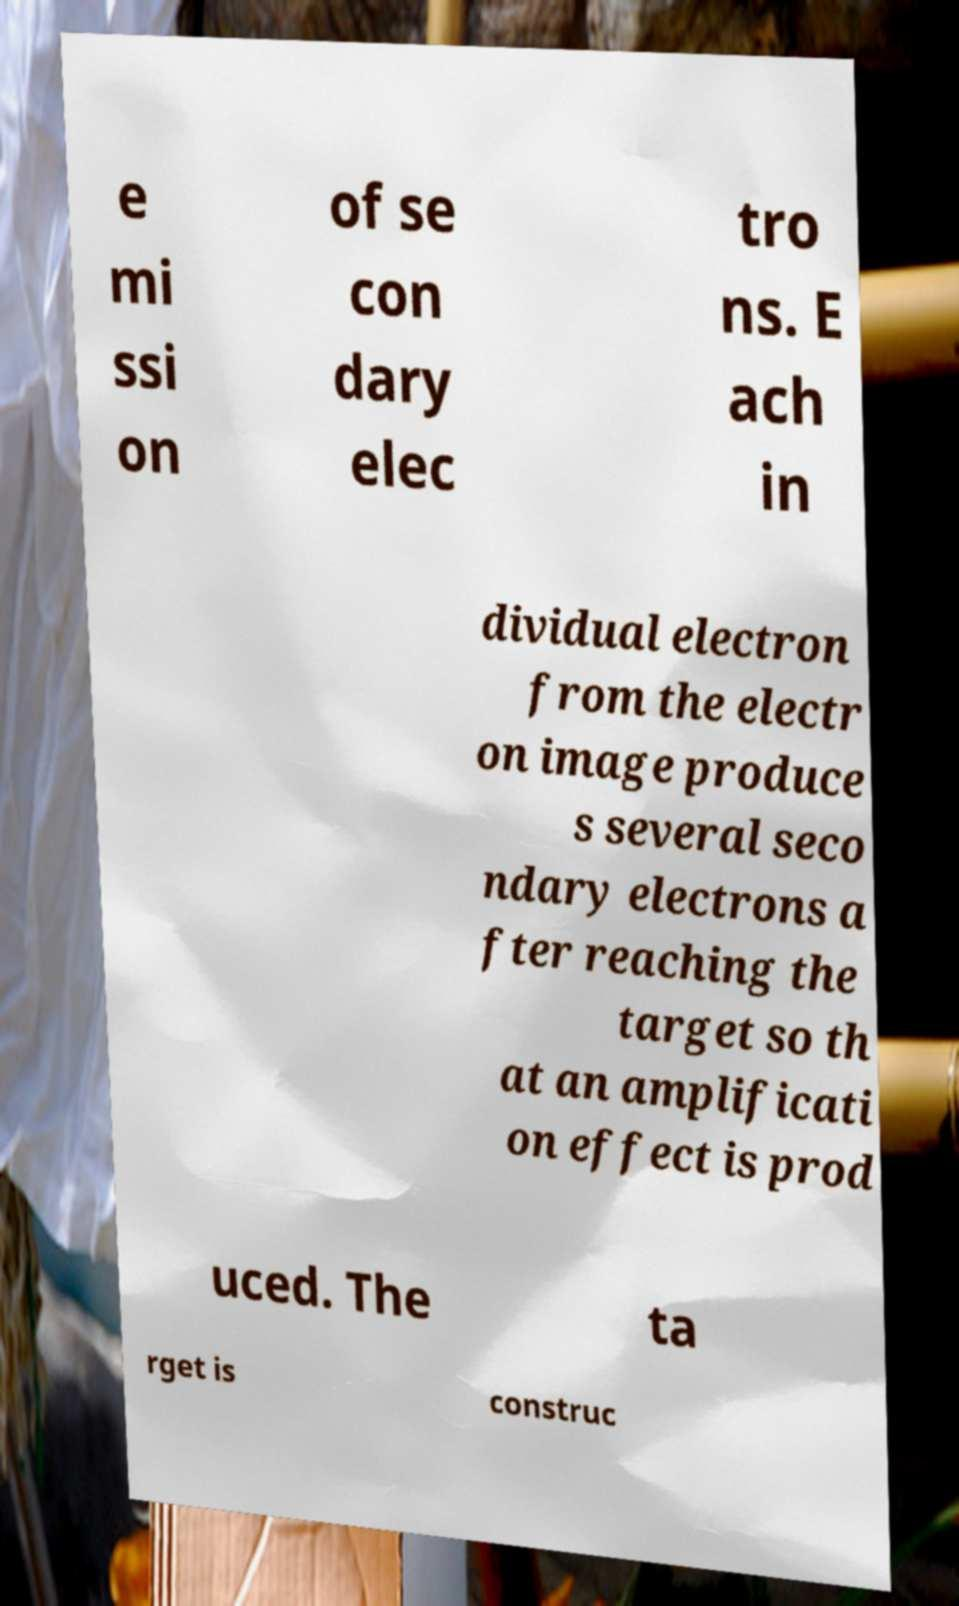Can you accurately transcribe the text from the provided image for me? e mi ssi on of se con dary elec tro ns. E ach in dividual electron from the electr on image produce s several seco ndary electrons a fter reaching the target so th at an amplificati on effect is prod uced. The ta rget is construc 